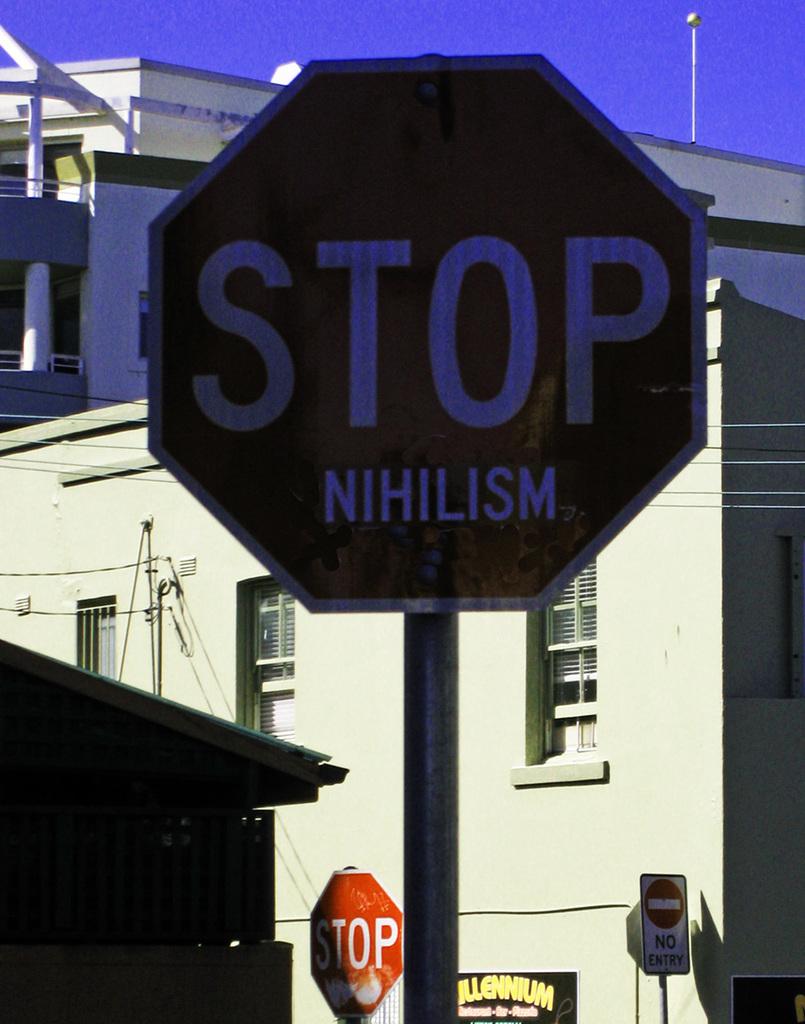What is the stop sign saying?
Your answer should be compact. Stop nihilism. What is on the sign?
Keep it short and to the point. Stop nihilism. 